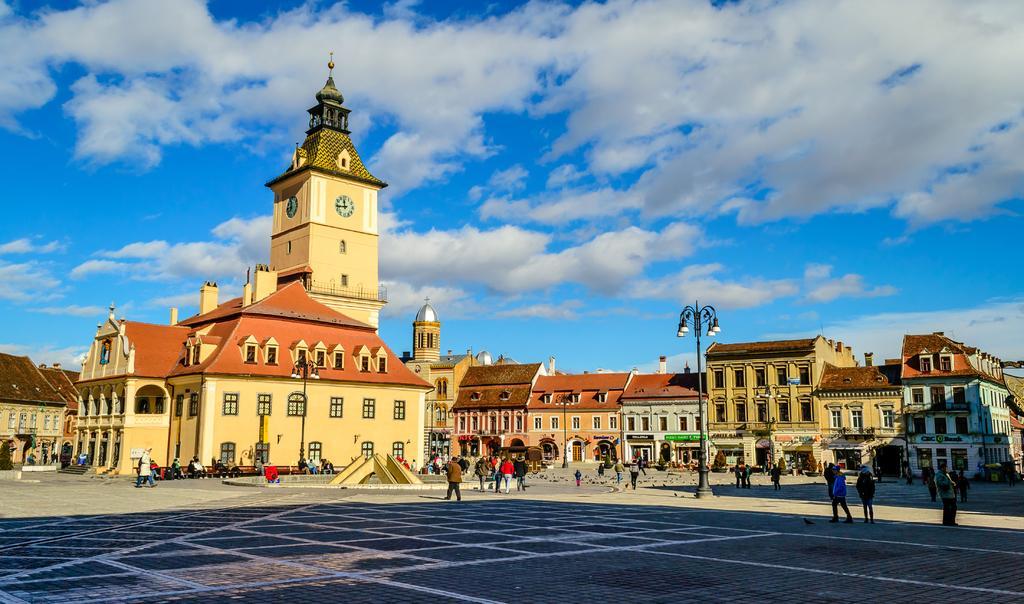In one or two sentences, can you explain what this image depicts? In the middle of the image few people are standing and walking and sitting on benches. Behind them there are some poles and buildings. At the top of the image there are some clouds and sky. 